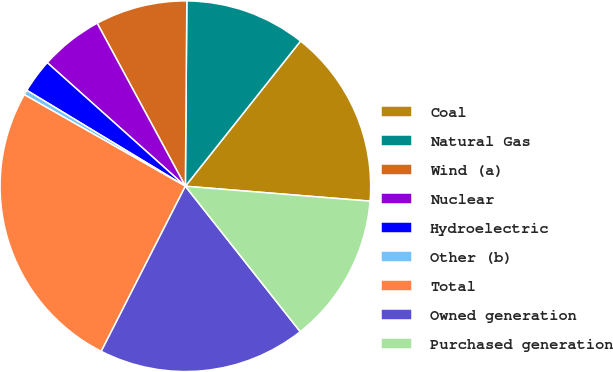<chart> <loc_0><loc_0><loc_500><loc_500><pie_chart><fcel>Coal<fcel>Natural Gas<fcel>Wind (a)<fcel>Nuclear<fcel>Hydroelectric<fcel>Other (b)<fcel>Total<fcel>Owned generation<fcel>Purchased generation<nl><fcel>15.61%<fcel>10.55%<fcel>8.02%<fcel>5.49%<fcel>2.96%<fcel>0.43%<fcel>25.73%<fcel>18.14%<fcel>13.08%<nl></chart> 